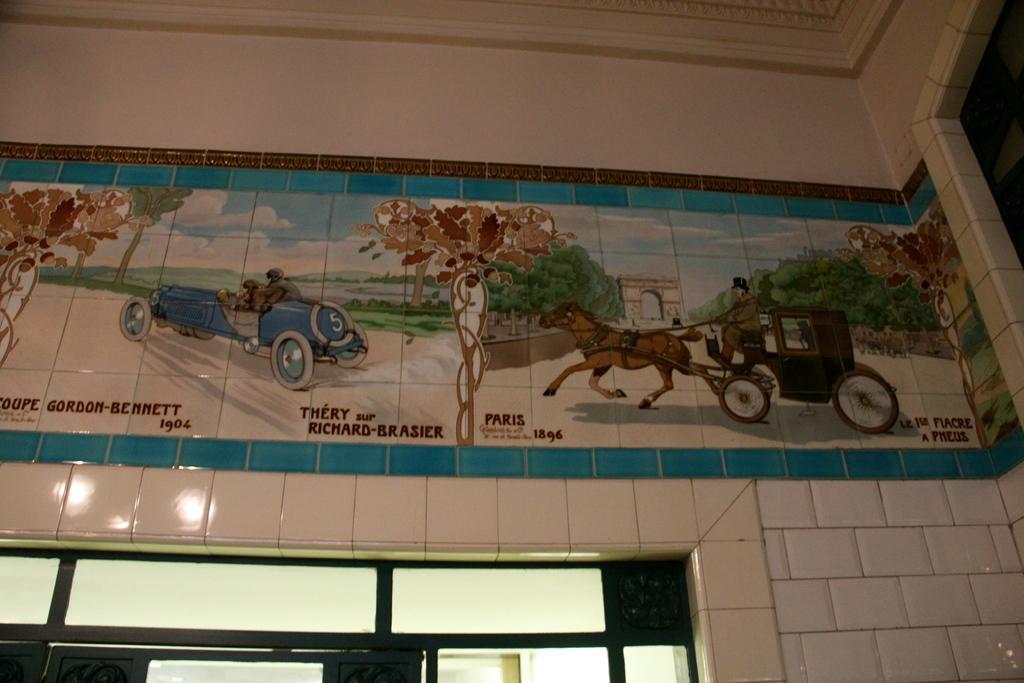Could you give a brief overview of what you see in this image? In the image we can see a wall, on the wall there is a painting. In the painting we can see some trees and arch and vehicle and cart. 